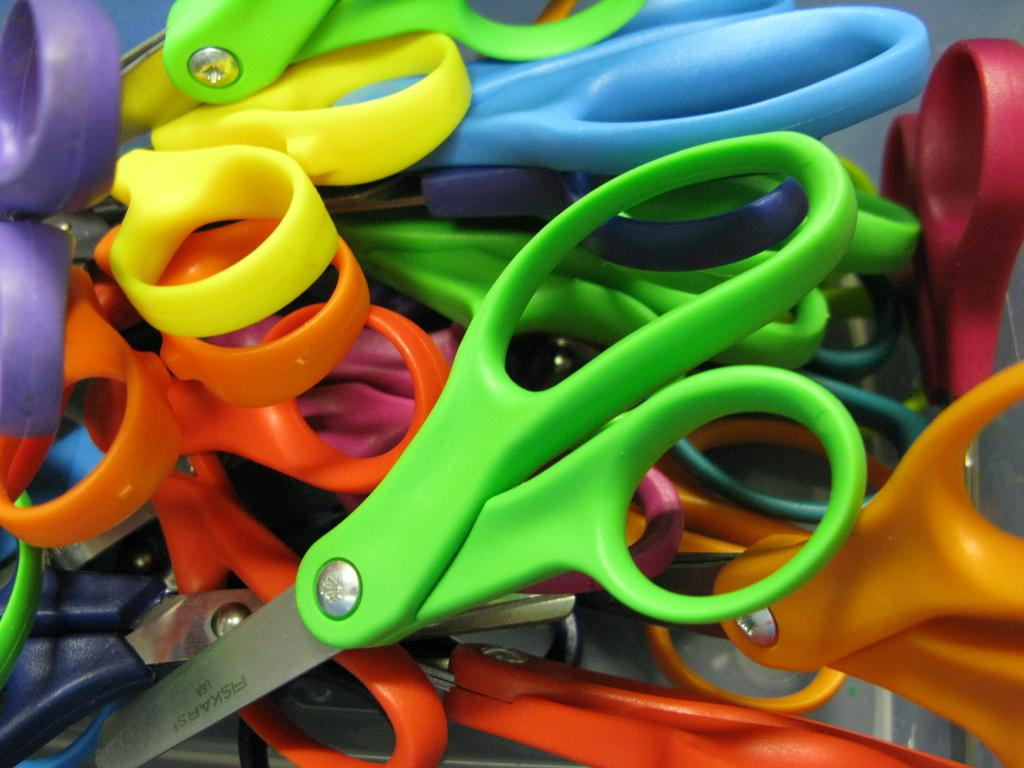What is the main subject of the image? The main subject of the image is many scissors. What can be observed about the scissors in the image? The scissors have colorful holders. How does the beginner learn to control their anger while using the scissors in the image? There is no indication in the image that the scissors are being used by a beginner or that they are related to controlling anger. What type of bread can be seen being cut by the scissors in the image? There is no bread present in the image, and therefore no such cutting activity can be observed. 